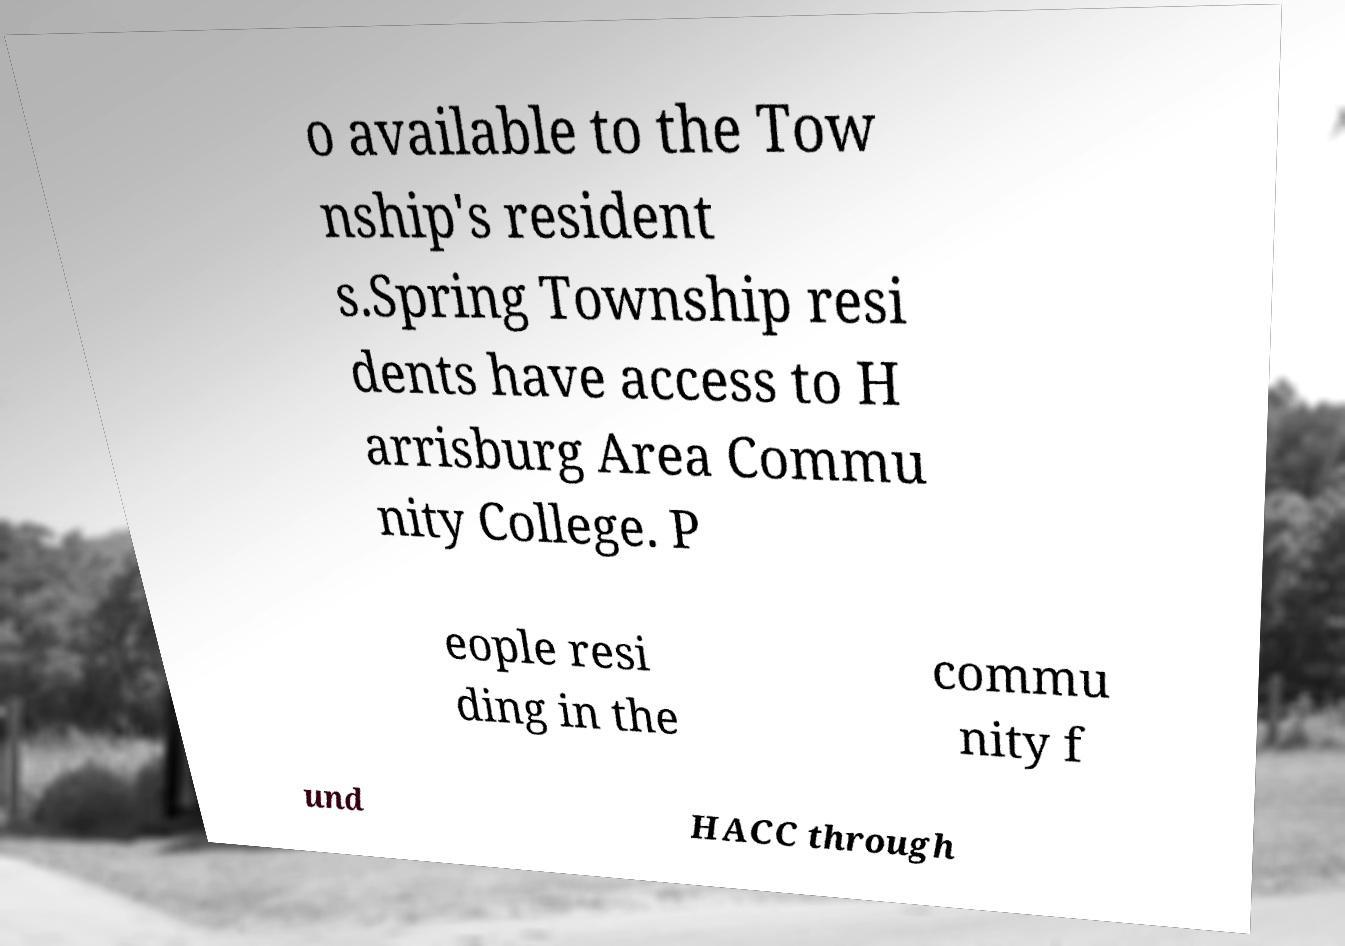Can you read and provide the text displayed in the image?This photo seems to have some interesting text. Can you extract and type it out for me? o available to the Tow nship's resident s.Spring Township resi dents have access to H arrisburg Area Commu nity College. P eople resi ding in the commu nity f und HACC through 